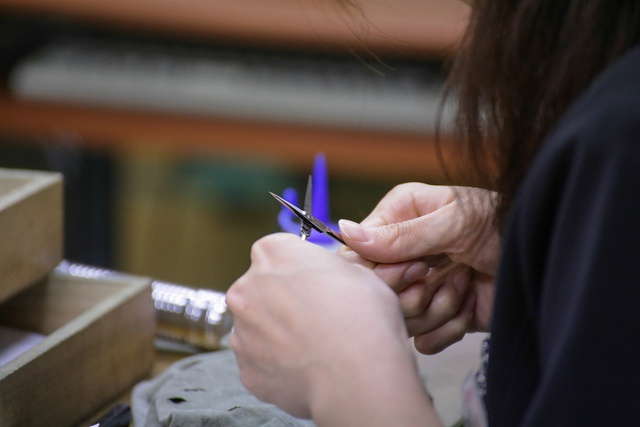Describe the objects in this image and their specific colors. I can see people in maroon, black, darkgray, and pink tones and scissors in maroon, gray, black, and blue tones in this image. 